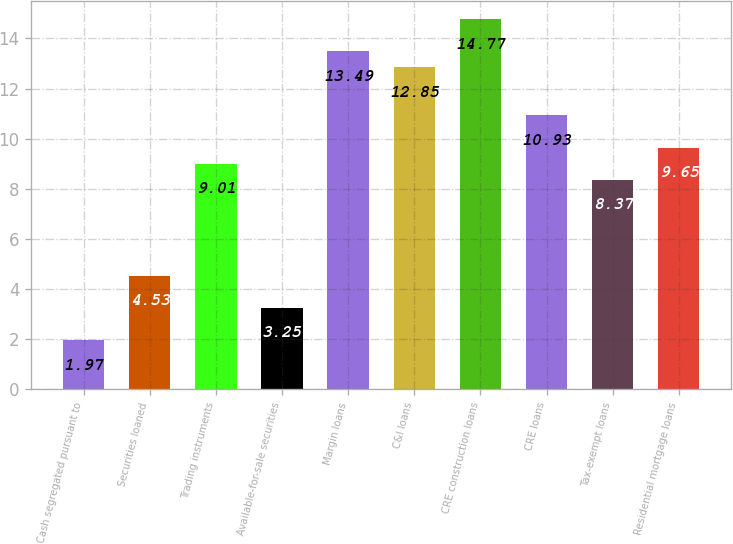Convert chart. <chart><loc_0><loc_0><loc_500><loc_500><bar_chart><fcel>Cash segregated pursuant to<fcel>Securities loaned<fcel>Trading instruments<fcel>Available-for-sale securities<fcel>Margin loans<fcel>C&I loans<fcel>CRE construction loans<fcel>CRE loans<fcel>Tax-exempt loans<fcel>Residential mortgage loans<nl><fcel>1.97<fcel>4.53<fcel>9.01<fcel>3.25<fcel>13.49<fcel>12.85<fcel>14.77<fcel>10.93<fcel>8.37<fcel>9.65<nl></chart> 